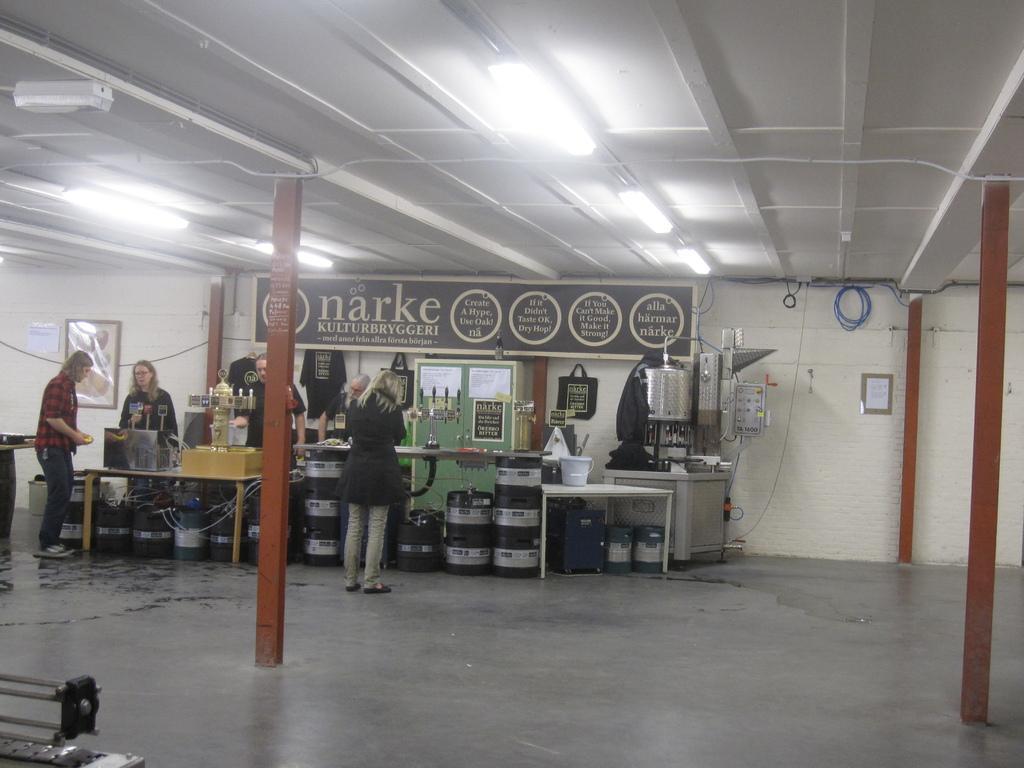Can you describe this image briefly? In this picture we can see pillars, some people standing on the floor, boxes, tables, bucket, cupboard, posters, bags, clothes and some objects and in the background we can see a frame on the wall, cables, ceiling and the lights. 